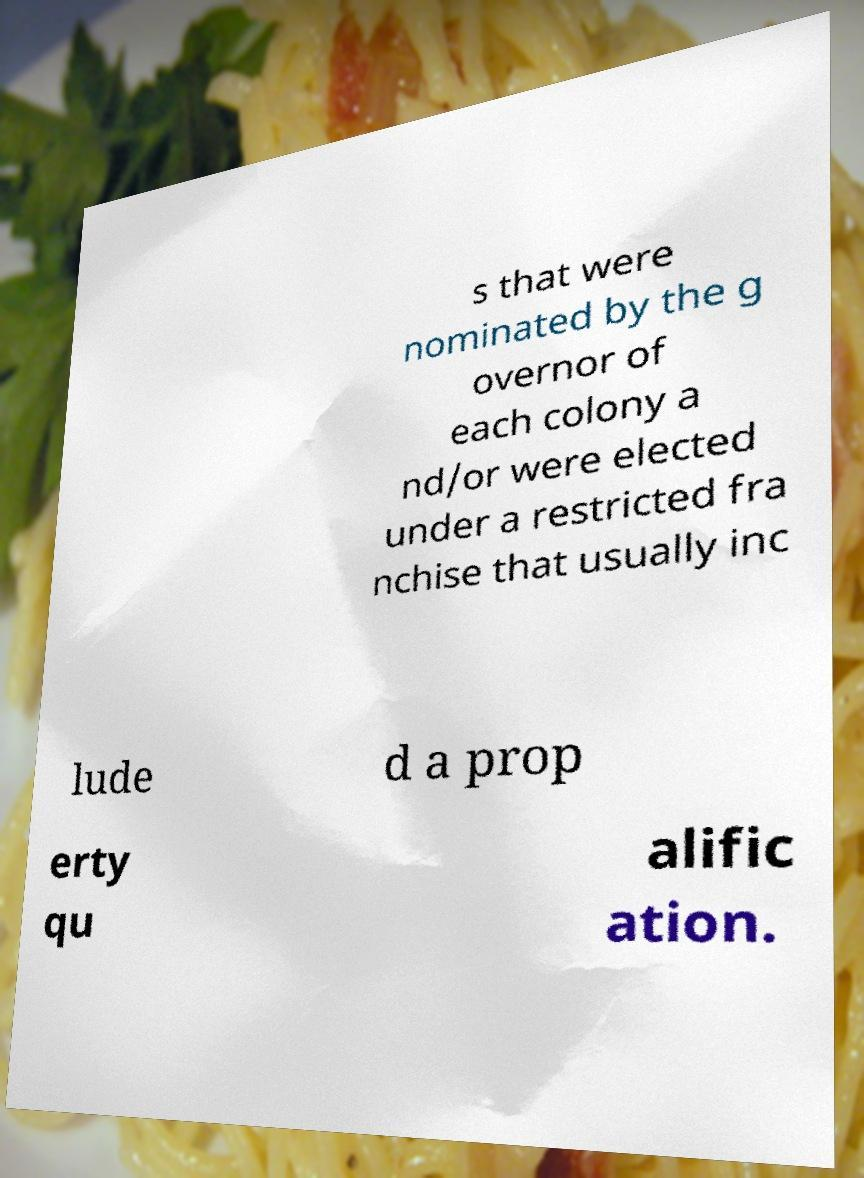I need the written content from this picture converted into text. Can you do that? s that were nominated by the g overnor of each colony a nd/or were elected under a restricted fra nchise that usually inc lude d a prop erty qu alific ation. 